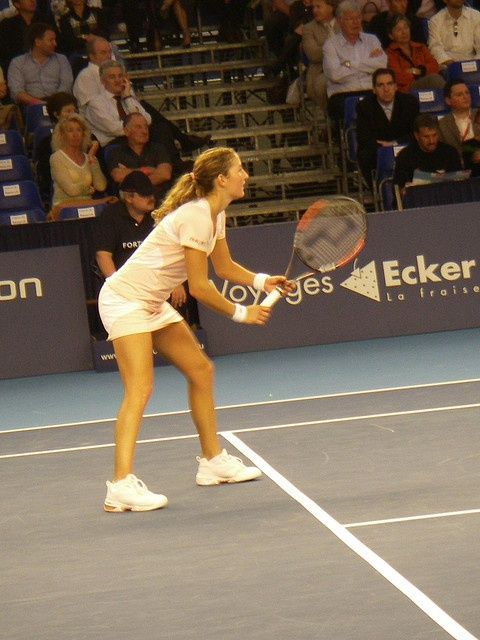Describe the objects in this image and their specific colors. I can see people in black, khaki, orange, and beige tones, people in black, maroon, and gray tones, people in black, brown, and maroon tones, tennis racket in black, gray, maroon, and brown tones, and people in black, gray, and maroon tones in this image. 